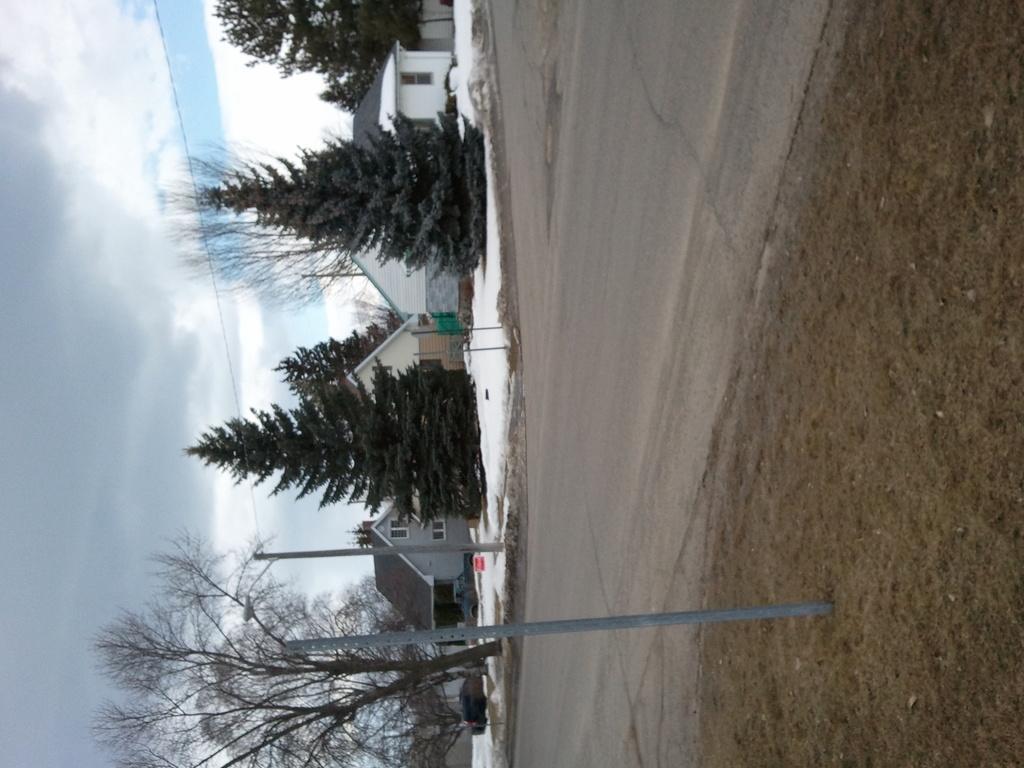How would you summarize this image in a sentence or two? These are the trees with branches and leaves. I can see two poles beside the road. These look like houses with windows. I think this is the snow. This looks like a car, which is parked. These are the clouds in the sky. Here is the grass. 